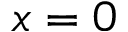<formula> <loc_0><loc_0><loc_500><loc_500>x = 0</formula> 